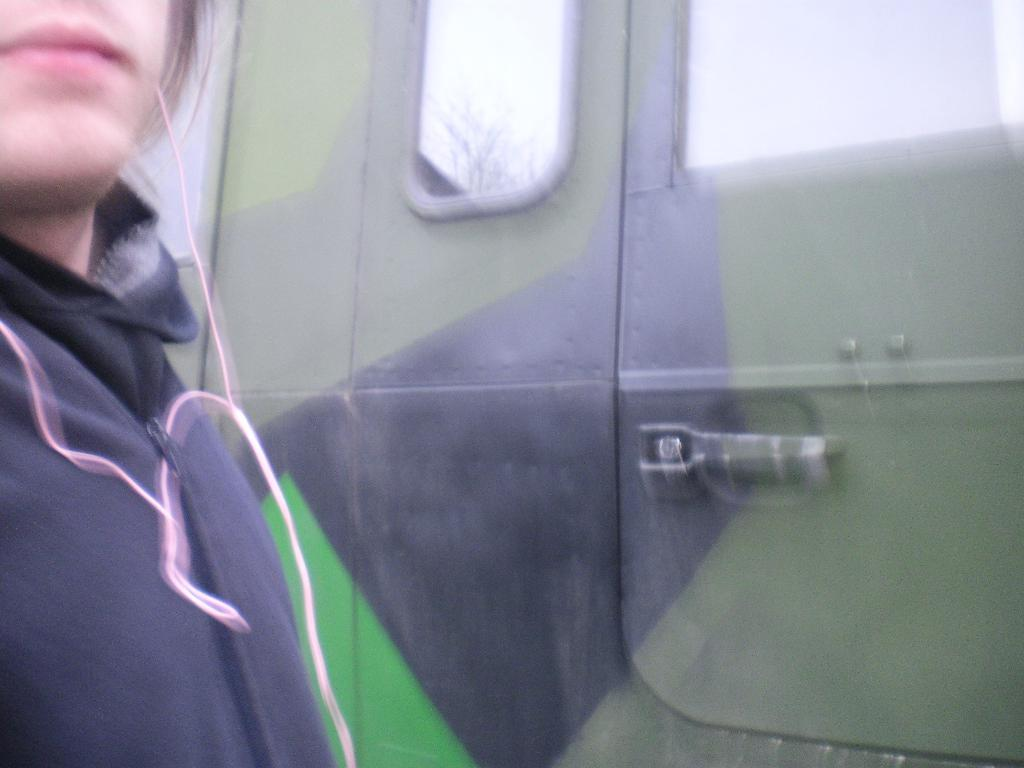What is the main subject of the image? There is a person in the image. What object can be seen in the background of the image? There is a door in the image. What type of beast can be seen visiting the person in the image? There is no beast present in the image, and therefore no such visit can be observed. 